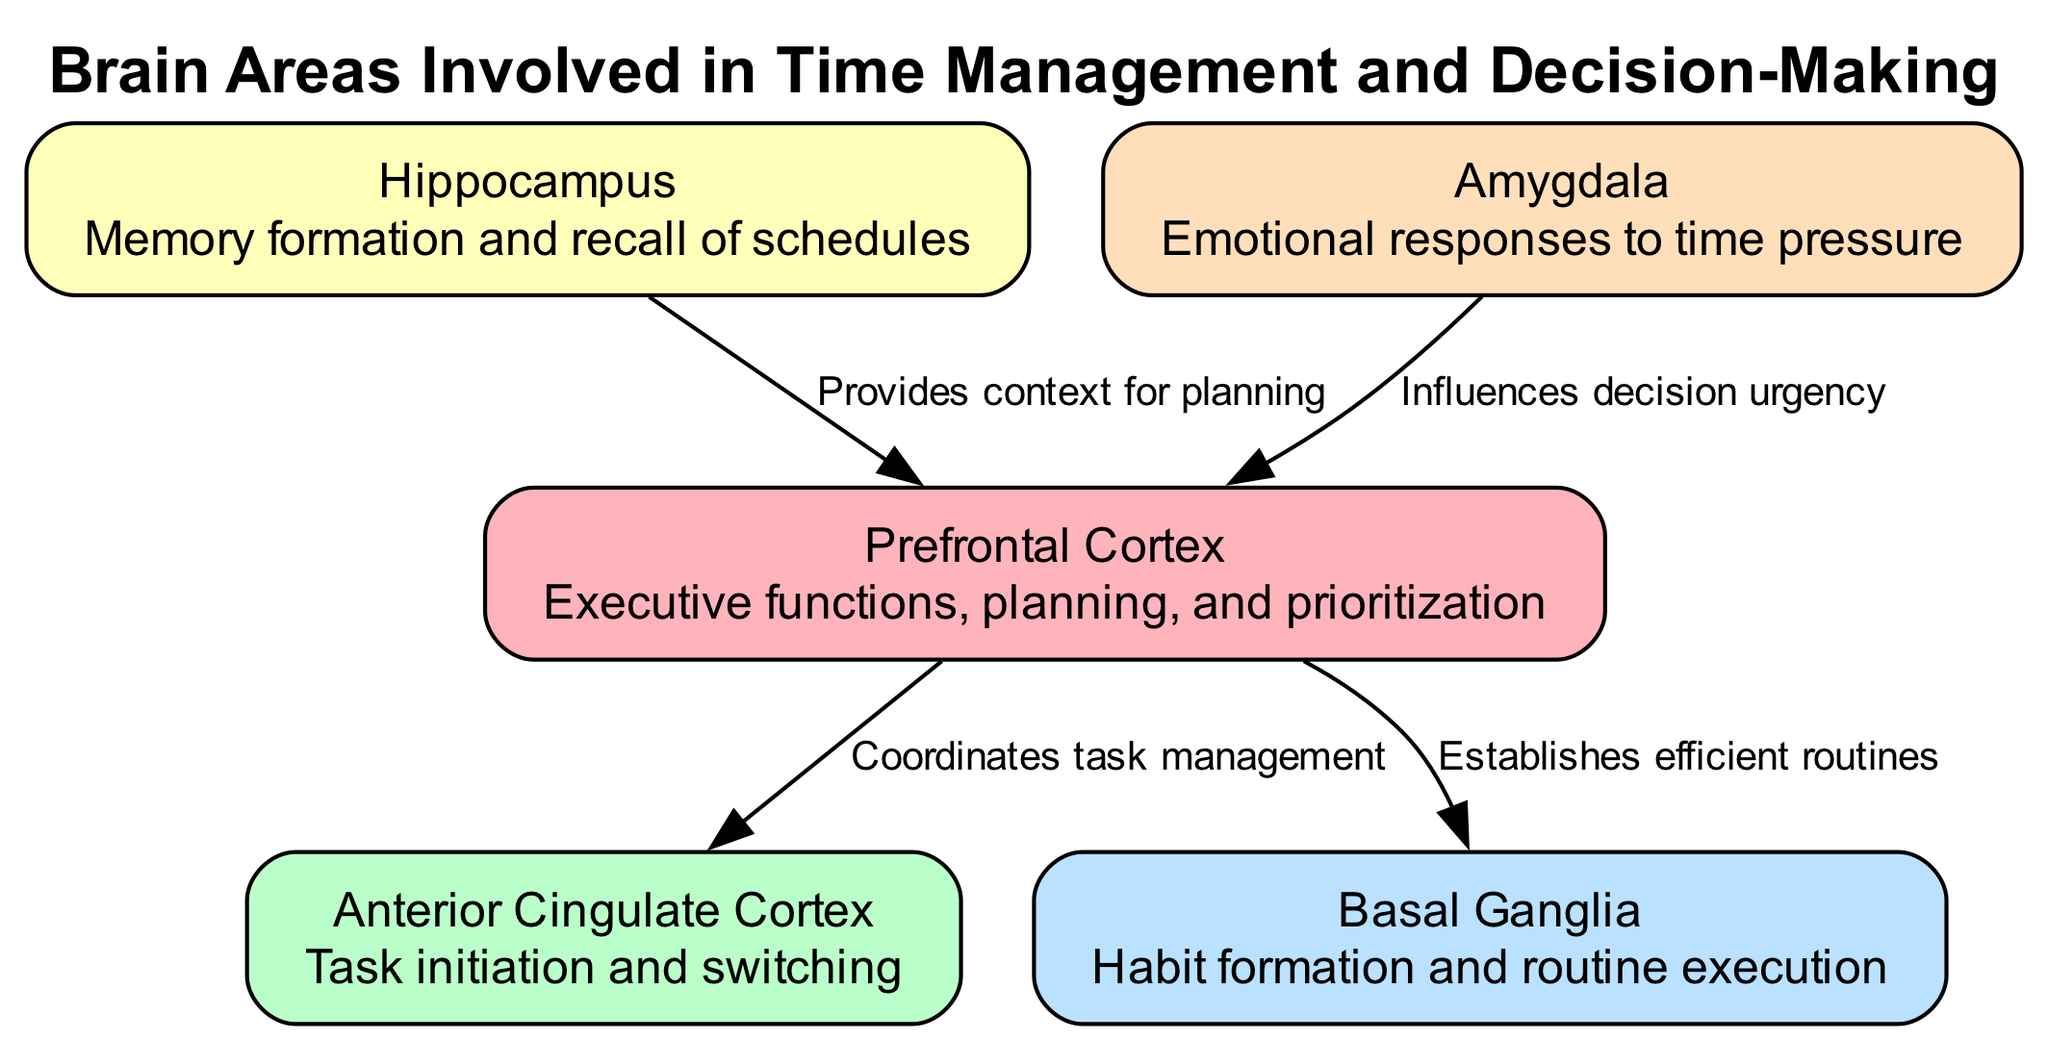How many nodes are in the diagram? The diagram contains five distinct nodes representing different brain areas involved in time management and decision-making. Each area is specifically labeled, and collectively, they are counted to determine the total.
Answer: 5 What is the role of the Prefrontal Cortex? The Prefrontal Cortex coordinates executive functions such as planning and prioritization, making it central to decision-making processes illustrated in the diagram.
Answer: Executive functions, planning, and prioritization What connections does the Anterior Cingulate Cortex have? The Anterior Cingulate Cortex has direct edges connecting it to the Prefrontal Cortex, signifying its role in task initiation and switching, and maintaining workflow.
Answer: Prefrontal Cortex Which area is responsible for emotional responses to time pressure? The diagram indicates the Amygdala specifically influences emotional responses related to the urgency of decision-making, highlighting its importance in time management contexts.
Answer: Amygdala How does the Hippocampus contribute to decision-making? The Hippocampus provides contextual information for planning, which supports the functions of the Prefrontal Cortex in effective decision-making and time management strategies.
Answer: Provides context for planning What is the relationship between the Basal Ganglia and the Prefrontal Cortex? The Basal Ganglia is connected to the Prefrontal Cortex, indicating that it contributes to establishing efficient routines, thereby streamlining the decision-making process.
Answer: Establishes efficient routines How many edges are present in the diagram? The diagram features four edges representing the connections and relationships between the brain areas. Each edge delineates a specific function or influence related to time management and decision-making.
Answer: 4 Which brain area aids in memory formation relevant to scheduling? The Hippocampus is identified as the area responsible for memory formation and recall, which is critical in managing schedules effectively as shown in the diagram.
Answer: Hippocampus What does the connection from the Amygdala to the Prefrontal Cortex signify? The flow from the Amygdala to the Prefrontal Cortex indicates that emotional responses from the Amygdala can influence how urgent decisions are assessed and made in the Prefrontal Cortex.
Answer: Influences decision urgency 